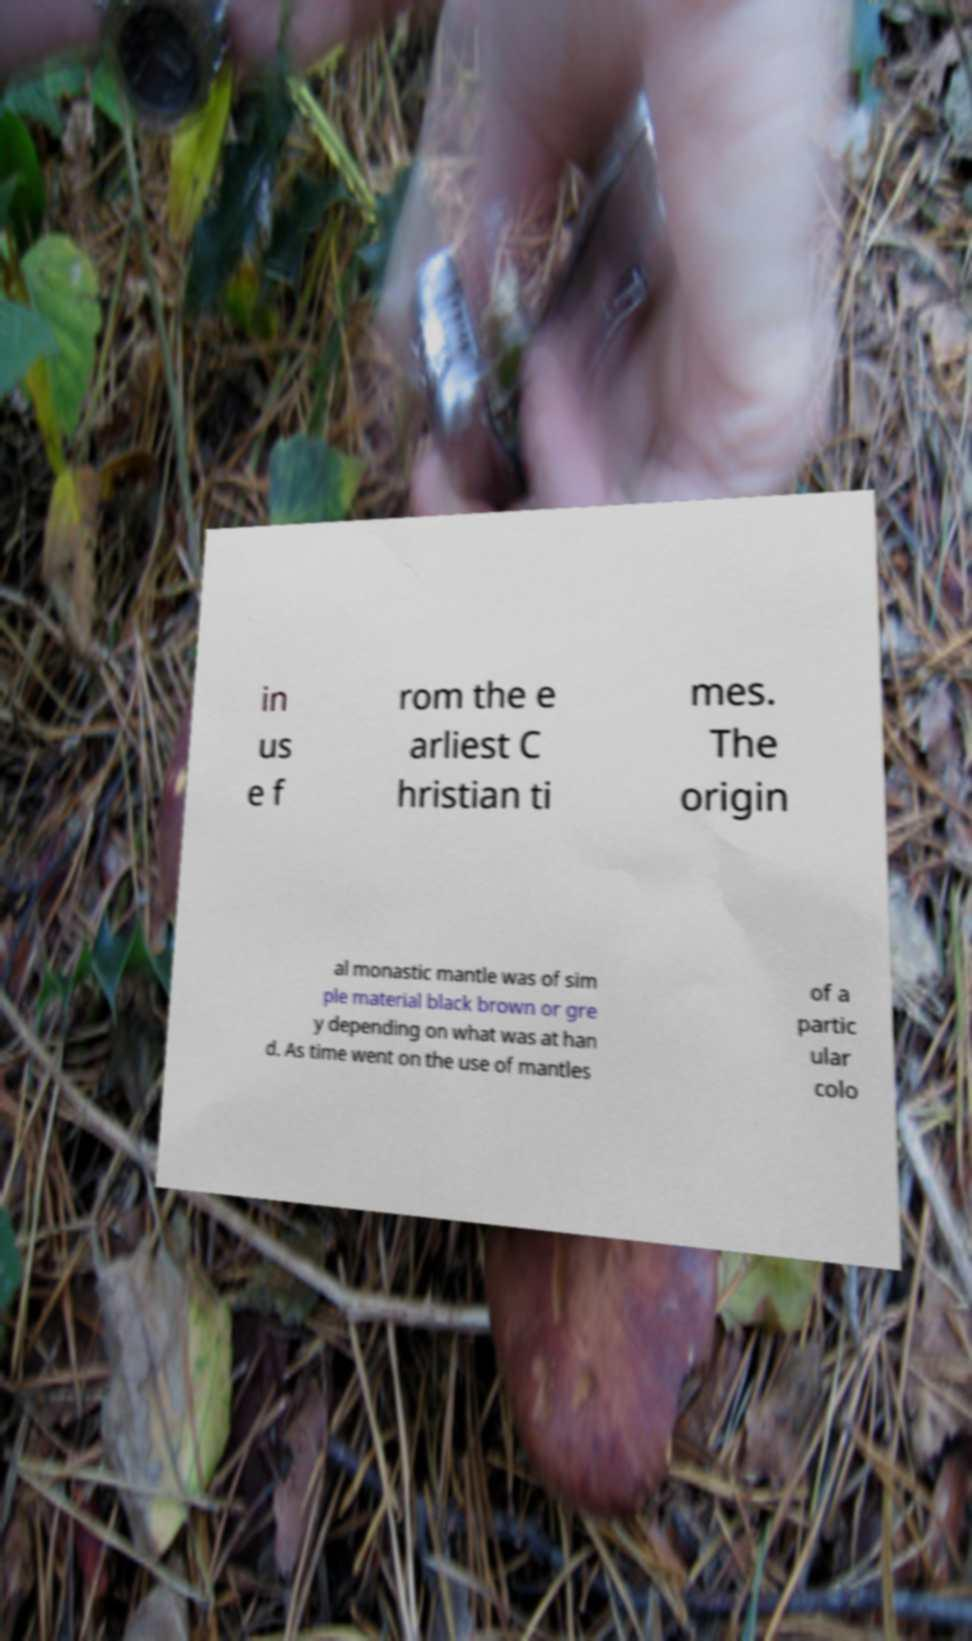Can you accurately transcribe the text from the provided image for me? in us e f rom the e arliest C hristian ti mes. The origin al monastic mantle was of sim ple material black brown or gre y depending on what was at han d. As time went on the use of mantles of a partic ular colo 